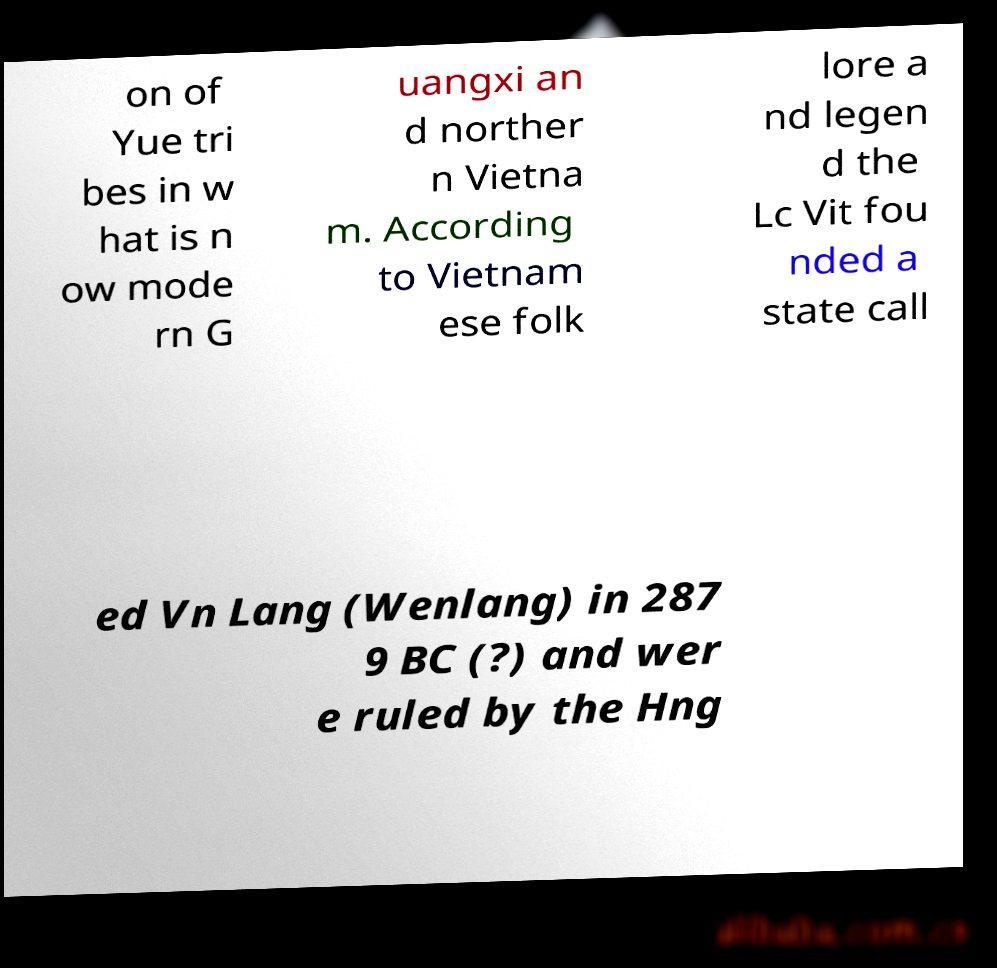Can you accurately transcribe the text from the provided image for me? on of Yue tri bes in w hat is n ow mode rn G uangxi an d norther n Vietna m. According to Vietnam ese folk lore a nd legen d the Lc Vit fou nded a state call ed Vn Lang (Wenlang) in 287 9 BC (?) and wer e ruled by the Hng 